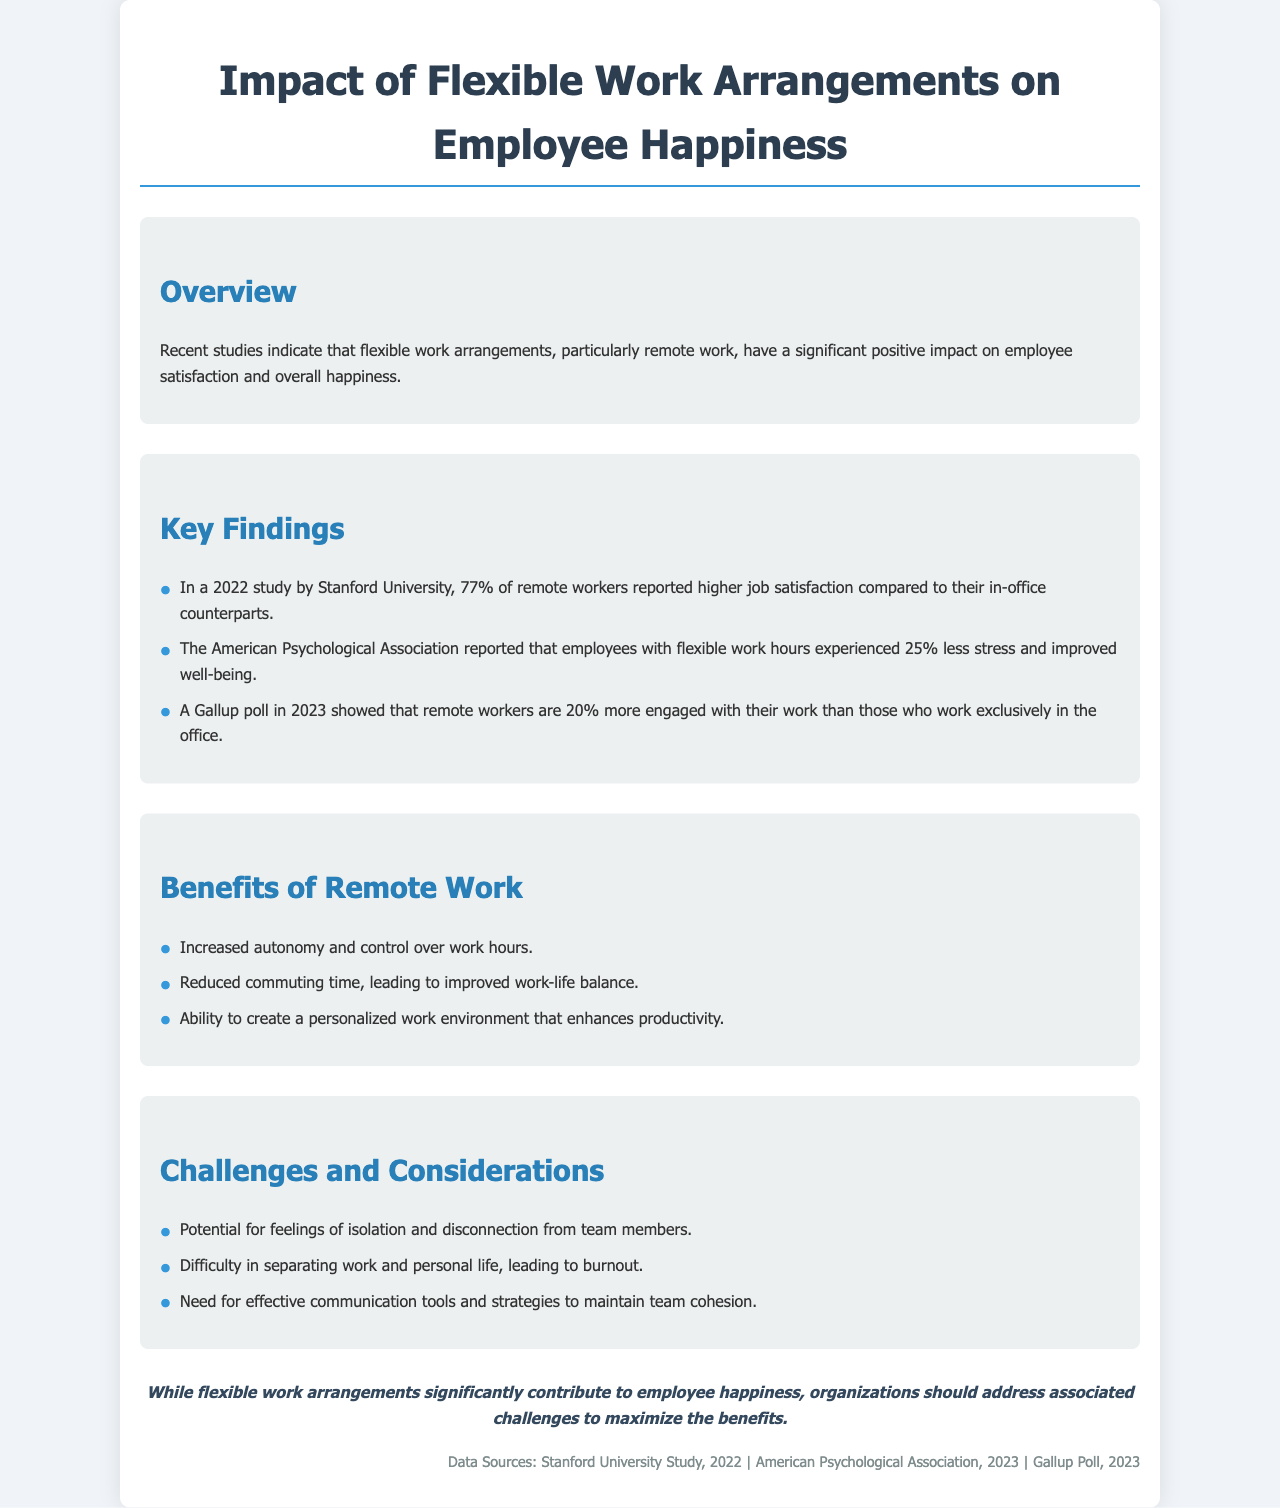what percentage of remote workers reported higher job satisfaction? According to the 2022 study by Stanford University, 77% of remote workers reported higher job satisfaction compared to their in-office counterparts.
Answer: 77% what was the reduction in stress experienced by employees with flexible work hours? The American Psychological Association reported that employees with flexible work hours experienced 25% less stress.
Answer: 25% which organization conducted a poll showing remote workers are more engaged? A Gallup poll in 2023 showed that remote workers are 20% more engaged than those who work exclusively in the office.
Answer: Gallup what is one benefit of remote work mentioned in the document? The document lists increased autonomy and control over work hours as a benefit of remote work.
Answer: Increased autonomy what challenge related to remote work is highlighted in the document? The document mentions the potential for feelings of isolation and disconnection from team members as a challenge.
Answer: Isolation what is a significant conclusion drawn from the findings? The conclusion discusses that organizations should address challenges to maximize the benefits of flexible work arrangements on employee happiness.
Answer: Address challenges which year did the Stanford University study take place? The Stanford University study referred to in the document was conducted in 2022.
Answer: 2022 what color is used for the heading text? The heading text color used in the document is #2c3e50.
Answer: #2c3e50 